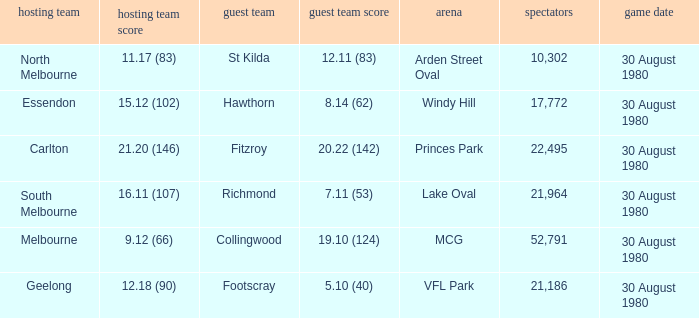What was the score for south melbourne at home? 16.11 (107). 